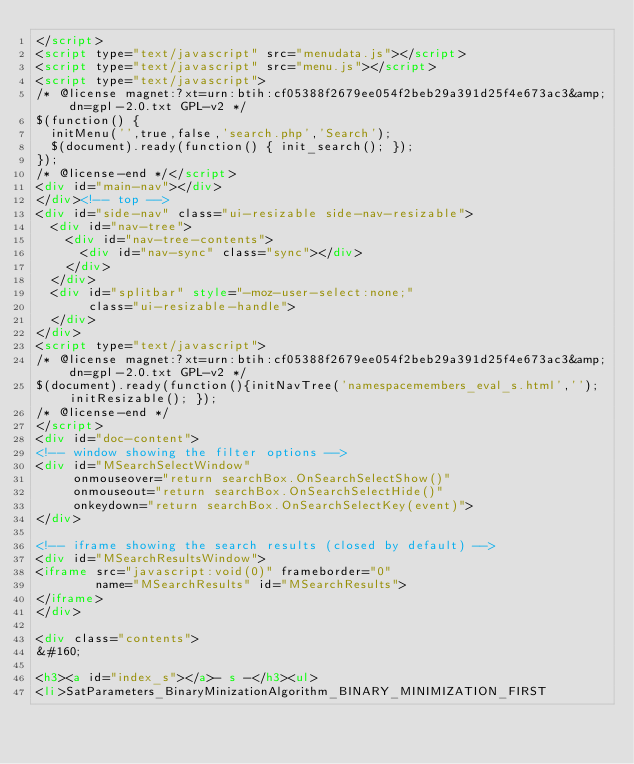Convert code to text. <code><loc_0><loc_0><loc_500><loc_500><_HTML_></script>
<script type="text/javascript" src="menudata.js"></script>
<script type="text/javascript" src="menu.js"></script>
<script type="text/javascript">
/* @license magnet:?xt=urn:btih:cf05388f2679ee054f2beb29a391d25f4e673ac3&amp;dn=gpl-2.0.txt GPL-v2 */
$(function() {
  initMenu('',true,false,'search.php','Search');
  $(document).ready(function() { init_search(); });
});
/* @license-end */</script>
<div id="main-nav"></div>
</div><!-- top -->
<div id="side-nav" class="ui-resizable side-nav-resizable">
  <div id="nav-tree">
    <div id="nav-tree-contents">
      <div id="nav-sync" class="sync"></div>
    </div>
  </div>
  <div id="splitbar" style="-moz-user-select:none;" 
       class="ui-resizable-handle">
  </div>
</div>
<script type="text/javascript">
/* @license magnet:?xt=urn:btih:cf05388f2679ee054f2beb29a391d25f4e673ac3&amp;dn=gpl-2.0.txt GPL-v2 */
$(document).ready(function(){initNavTree('namespacemembers_eval_s.html',''); initResizable(); });
/* @license-end */
</script>
<div id="doc-content">
<!-- window showing the filter options -->
<div id="MSearchSelectWindow"
     onmouseover="return searchBox.OnSearchSelectShow()"
     onmouseout="return searchBox.OnSearchSelectHide()"
     onkeydown="return searchBox.OnSearchSelectKey(event)">
</div>

<!-- iframe showing the search results (closed by default) -->
<div id="MSearchResultsWindow">
<iframe src="javascript:void(0)" frameborder="0" 
        name="MSearchResults" id="MSearchResults">
</iframe>
</div>

<div class="contents">
&#160;

<h3><a id="index_s"></a>- s -</h3><ul>
<li>SatParameters_BinaryMinizationAlgorithm_BINARY_MINIMIZATION_FIRST</code> 